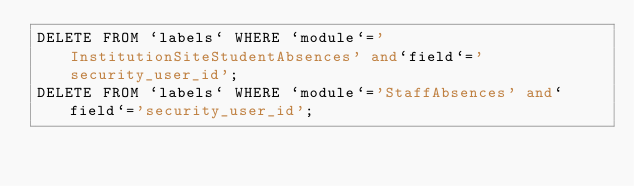Convert code to text. <code><loc_0><loc_0><loc_500><loc_500><_SQL_>DELETE FROM `labels` WHERE `module`='InstitutionSiteStudentAbsences' and`field`='security_user_id';
DELETE FROM `labels` WHERE `module`='StaffAbsences' and`field`='security_user_id';</code> 